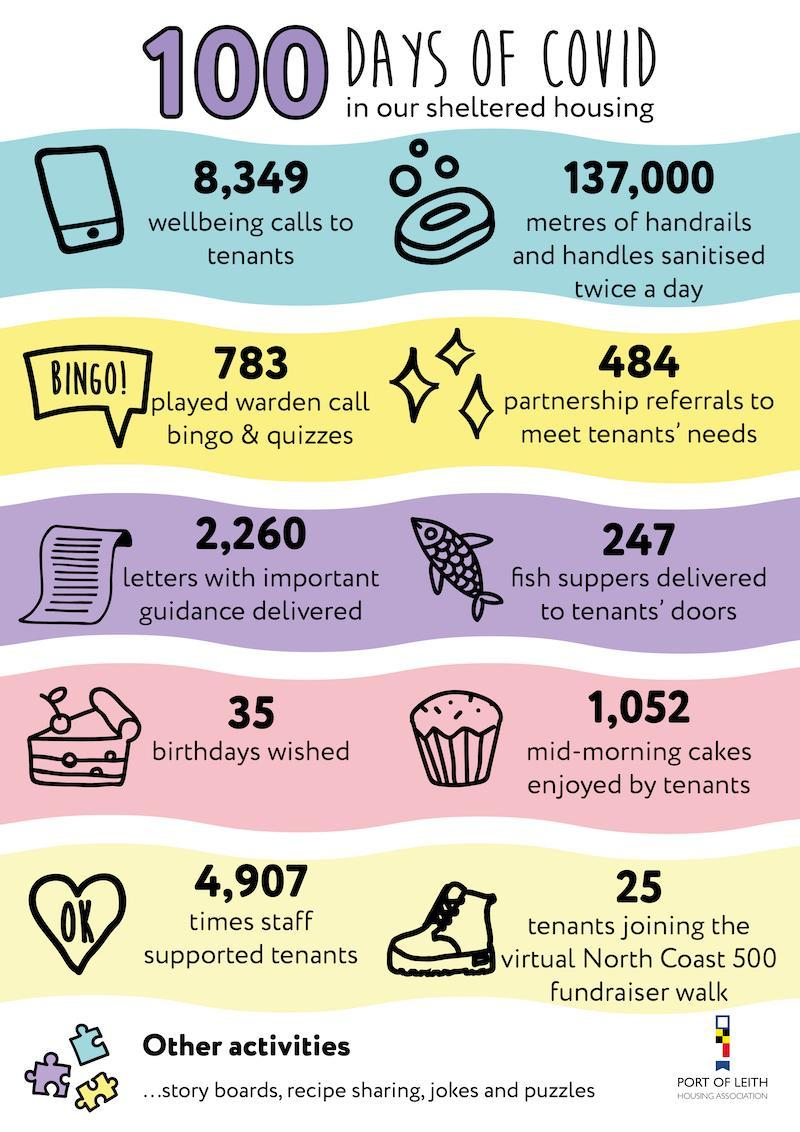How many wellbeing calls were made to the tenants by the Port of Leith Housing Association during COVID-19 time?
Answer the question with a short phrase. 8,349 How many times the staffs of  Port of Leith Housing Association supported the tenants during COVID-19 time? 4,907 How many fish suppers were delivered to tenants' door during COVID-19 time by the Port of Leith Housing Association? 247 